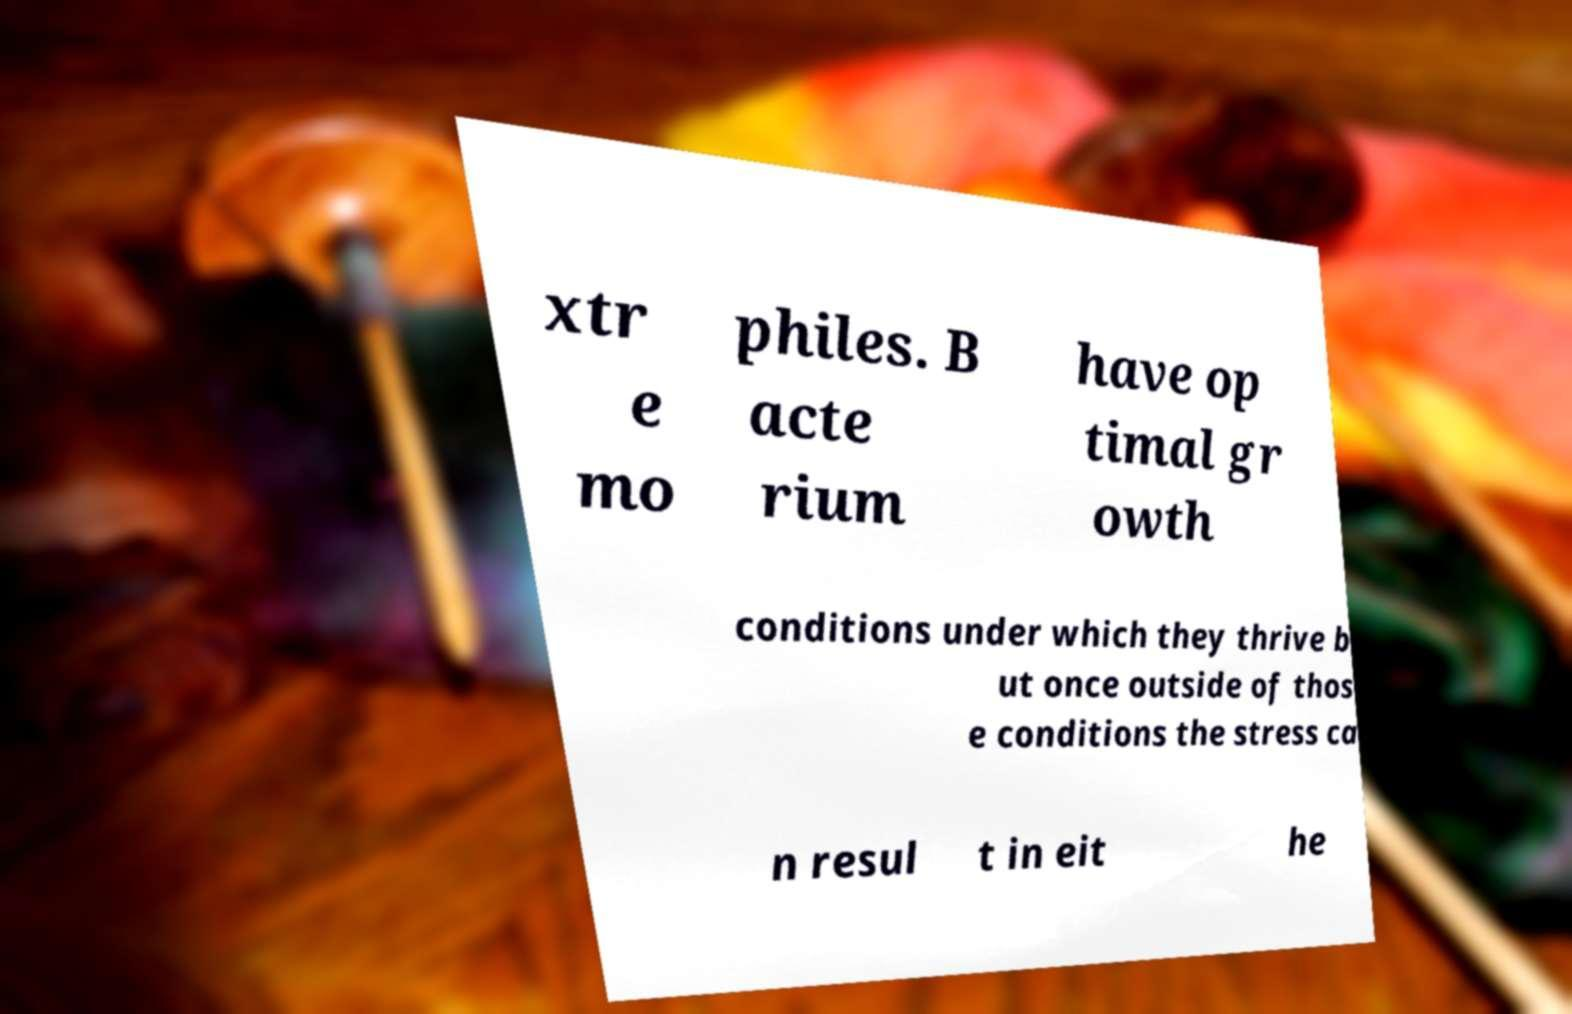Can you accurately transcribe the text from the provided image for me? xtr e mo philes. B acte rium have op timal gr owth conditions under which they thrive b ut once outside of thos e conditions the stress ca n resul t in eit he 